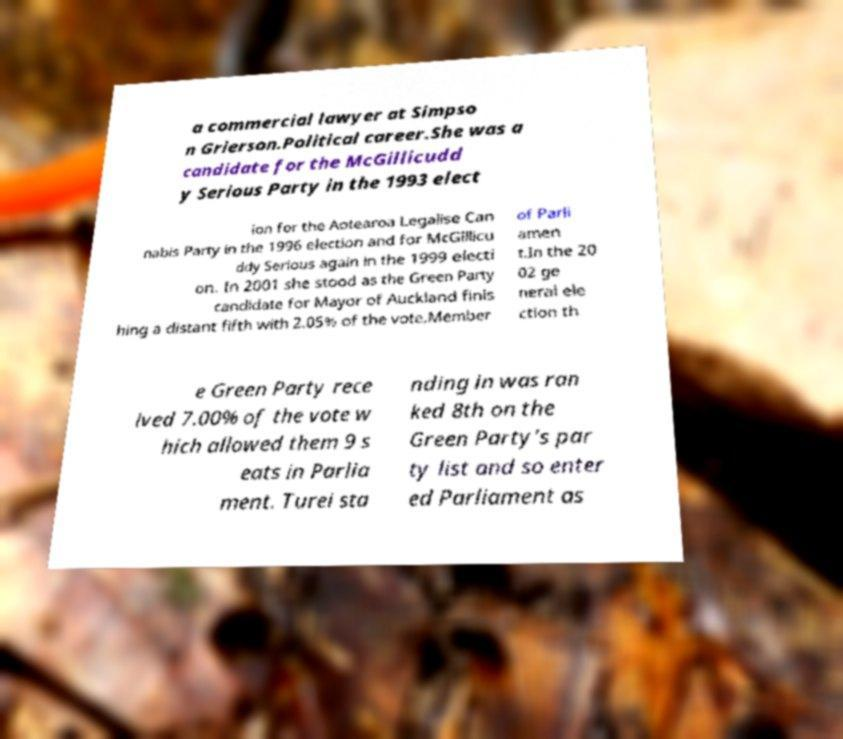Can you accurately transcribe the text from the provided image for me? a commercial lawyer at Simpso n Grierson.Political career.She was a candidate for the McGillicudd y Serious Party in the 1993 elect ion for the Aotearoa Legalise Can nabis Party in the 1996 election and for McGillicu ddy Serious again in the 1999 electi on. In 2001 she stood as the Green Party candidate for Mayor of Auckland finis hing a distant fifth with 2.05% of the vote.Member of Parli amen t.In the 20 02 ge neral ele ction th e Green Party rece ived 7.00% of the vote w hich allowed them 9 s eats in Parlia ment. Turei sta nding in was ran ked 8th on the Green Party's par ty list and so enter ed Parliament as 